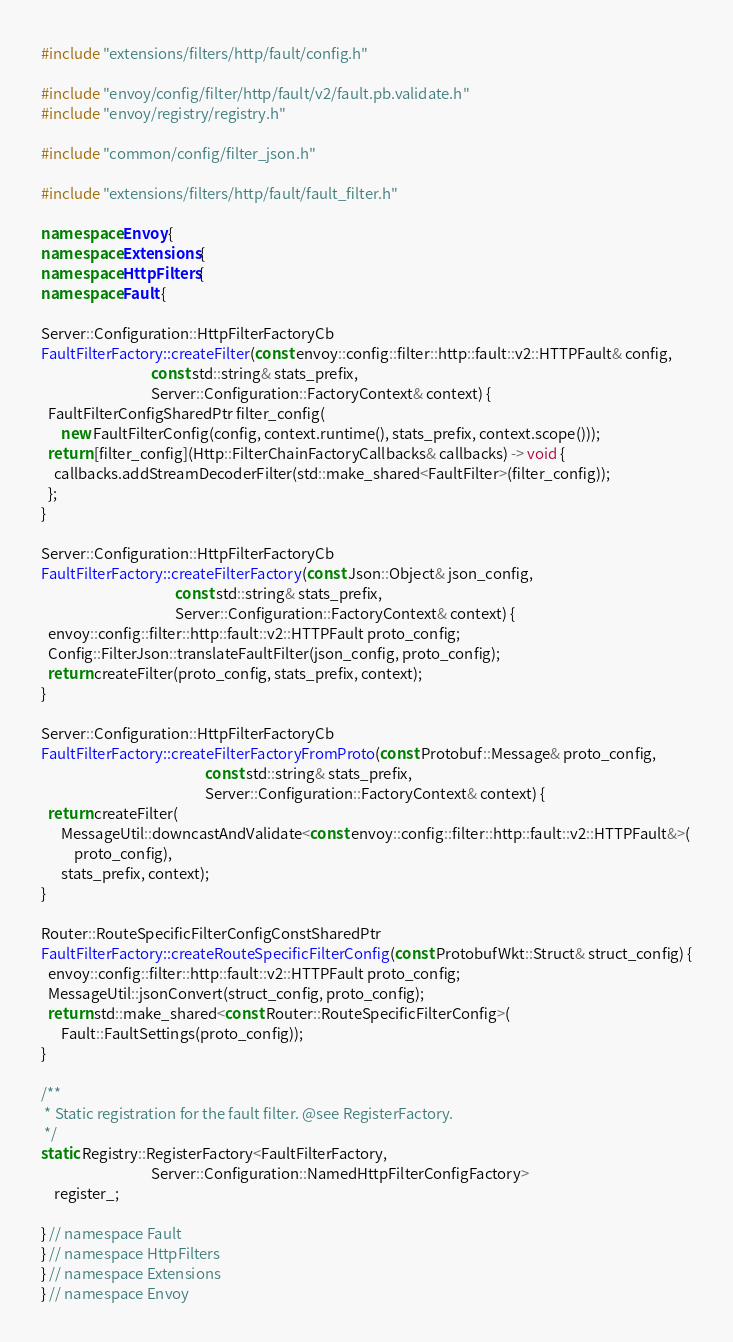<code> <loc_0><loc_0><loc_500><loc_500><_C++_>#include "extensions/filters/http/fault/config.h"

#include "envoy/config/filter/http/fault/v2/fault.pb.validate.h"
#include "envoy/registry/registry.h"

#include "common/config/filter_json.h"

#include "extensions/filters/http/fault/fault_filter.h"

namespace Envoy {
namespace Extensions {
namespace HttpFilters {
namespace Fault {

Server::Configuration::HttpFilterFactoryCb
FaultFilterFactory::createFilter(const envoy::config::filter::http::fault::v2::HTTPFault& config,
                                 const std::string& stats_prefix,
                                 Server::Configuration::FactoryContext& context) {
  FaultFilterConfigSharedPtr filter_config(
      new FaultFilterConfig(config, context.runtime(), stats_prefix, context.scope()));
  return [filter_config](Http::FilterChainFactoryCallbacks& callbacks) -> void {
    callbacks.addStreamDecoderFilter(std::make_shared<FaultFilter>(filter_config));
  };
}

Server::Configuration::HttpFilterFactoryCb
FaultFilterFactory::createFilterFactory(const Json::Object& json_config,
                                        const std::string& stats_prefix,
                                        Server::Configuration::FactoryContext& context) {
  envoy::config::filter::http::fault::v2::HTTPFault proto_config;
  Config::FilterJson::translateFaultFilter(json_config, proto_config);
  return createFilter(proto_config, stats_prefix, context);
}

Server::Configuration::HttpFilterFactoryCb
FaultFilterFactory::createFilterFactoryFromProto(const Protobuf::Message& proto_config,
                                                 const std::string& stats_prefix,
                                                 Server::Configuration::FactoryContext& context) {
  return createFilter(
      MessageUtil::downcastAndValidate<const envoy::config::filter::http::fault::v2::HTTPFault&>(
          proto_config),
      stats_prefix, context);
}

Router::RouteSpecificFilterConfigConstSharedPtr
FaultFilterFactory::createRouteSpecificFilterConfig(const ProtobufWkt::Struct& struct_config) {
  envoy::config::filter::http::fault::v2::HTTPFault proto_config;
  MessageUtil::jsonConvert(struct_config, proto_config);
  return std::make_shared<const Router::RouteSpecificFilterConfig>(
      Fault::FaultSettings(proto_config));
}

/**
 * Static registration for the fault filter. @see RegisterFactory.
 */
static Registry::RegisterFactory<FaultFilterFactory,
                                 Server::Configuration::NamedHttpFilterConfigFactory>
    register_;

} // namespace Fault
} // namespace HttpFilters
} // namespace Extensions
} // namespace Envoy
</code> 